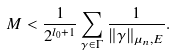<formula> <loc_0><loc_0><loc_500><loc_500>M < \frac { 1 } { 2 ^ { l _ { 0 } + 1 } } \sum _ { \gamma \in \Gamma } \frac { 1 } { \| \gamma \| _ { \mu _ { n } , E } } .</formula> 